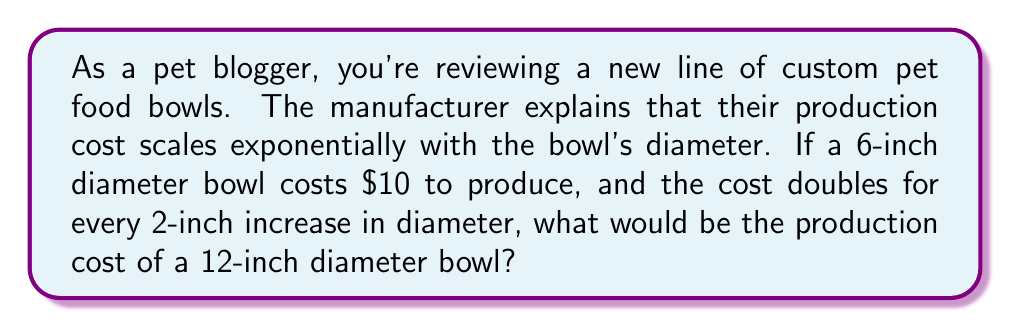Could you help me with this problem? Let's approach this step-by-step:

1) First, we need to identify the exponential relationship:
   - Cost doubles every 2 inches
   - This can be expressed as: $\text{Cost} = \text{Initial Cost} \times 2^{\text{number of 2-inch increases}}$

2) Let's define our variables:
   - Initial cost: $C_0 = \$10$
   - Initial diameter: $d_0 = 6$ inches
   - Final diameter: $d_f = 12$ inches

3) Calculate the number of 2-inch increases:
   $\text{Number of increases} = \frac{d_f - d_0}{2} = \frac{12 - 6}{2} = 3$

4) Now we can set up our exponential equation:
   $\text{Final Cost} = C_0 \times 2^3$

5) Calculate:
   $\text{Final Cost} = \$10 \times 2^3 = \$10 \times 8 = \$80$

Therefore, the production cost of a 12-inch diameter bowl would be $80.
Answer: $80 